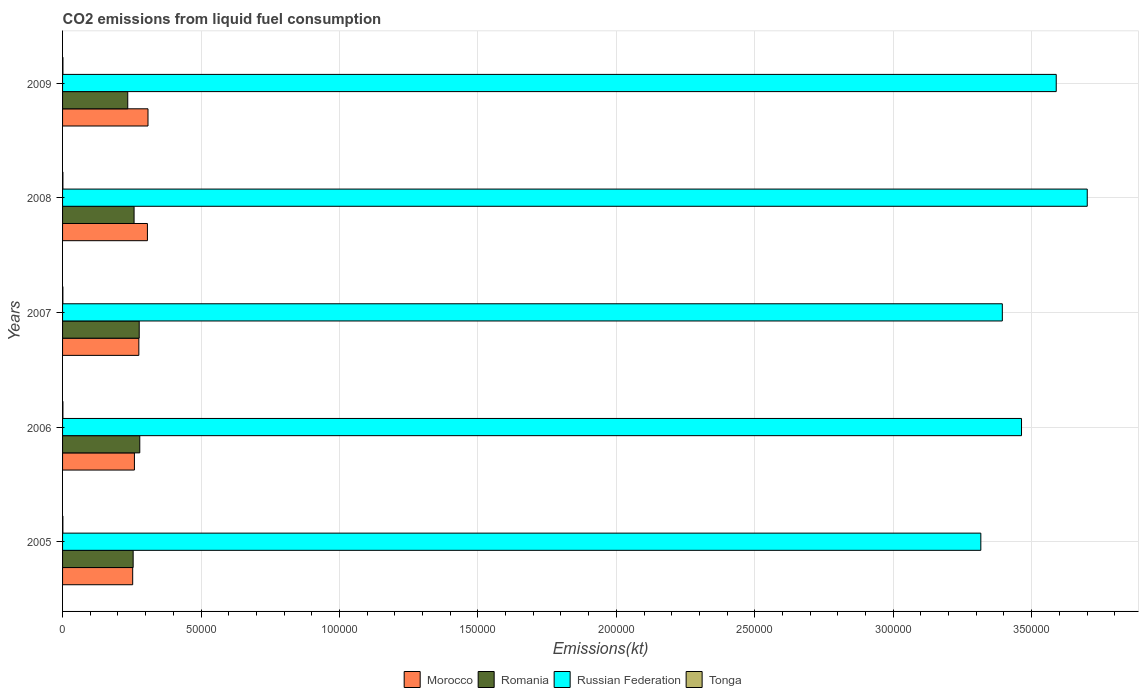How many different coloured bars are there?
Give a very brief answer. 4. How many groups of bars are there?
Provide a short and direct response. 5. Are the number of bars per tick equal to the number of legend labels?
Provide a succinct answer. Yes. Are the number of bars on each tick of the Y-axis equal?
Your answer should be compact. Yes. How many bars are there on the 4th tick from the top?
Offer a terse response. 4. How many bars are there on the 5th tick from the bottom?
Your response must be concise. 4. In how many cases, is the number of bars for a given year not equal to the number of legend labels?
Make the answer very short. 0. What is the amount of CO2 emitted in Morocco in 2005?
Make the answer very short. 2.53e+04. Across all years, what is the maximum amount of CO2 emitted in Russian Federation?
Your answer should be very brief. 3.70e+05. Across all years, what is the minimum amount of CO2 emitted in Russian Federation?
Offer a terse response. 3.32e+05. In which year was the amount of CO2 emitted in Tonga maximum?
Provide a succinct answer. 2009. In which year was the amount of CO2 emitted in Romania minimum?
Keep it short and to the point. 2009. What is the total amount of CO2 emitted in Russian Federation in the graph?
Ensure brevity in your answer.  1.75e+06. What is the difference between the amount of CO2 emitted in Morocco in 2006 and that in 2007?
Provide a short and direct response. -1595.14. What is the difference between the amount of CO2 emitted in Russian Federation in 2008 and the amount of CO2 emitted in Morocco in 2007?
Provide a short and direct response. 3.43e+05. What is the average amount of CO2 emitted in Morocco per year?
Keep it short and to the point. 2.81e+04. In the year 2006, what is the difference between the amount of CO2 emitted in Tonga and amount of CO2 emitted in Russian Federation?
Your answer should be very brief. -3.46e+05. What is the ratio of the amount of CO2 emitted in Romania in 2006 to that in 2008?
Ensure brevity in your answer.  1.08. Is the amount of CO2 emitted in Romania in 2007 less than that in 2008?
Offer a very short reply. No. Is the difference between the amount of CO2 emitted in Tonga in 2006 and 2007 greater than the difference between the amount of CO2 emitted in Russian Federation in 2006 and 2007?
Keep it short and to the point. No. What is the difference between the highest and the second highest amount of CO2 emitted in Romania?
Your answer should be very brief. 205.35. What is the difference between the highest and the lowest amount of CO2 emitted in Morocco?
Make the answer very short. 5529.84. In how many years, is the amount of CO2 emitted in Russian Federation greater than the average amount of CO2 emitted in Russian Federation taken over all years?
Your answer should be very brief. 2. Is the sum of the amount of CO2 emitted in Morocco in 2005 and 2009 greater than the maximum amount of CO2 emitted in Russian Federation across all years?
Give a very brief answer. No. Is it the case that in every year, the sum of the amount of CO2 emitted in Romania and amount of CO2 emitted in Tonga is greater than the sum of amount of CO2 emitted in Russian Federation and amount of CO2 emitted in Morocco?
Your response must be concise. No. What does the 1st bar from the top in 2006 represents?
Make the answer very short. Tonga. What does the 4th bar from the bottom in 2009 represents?
Make the answer very short. Tonga. How many bars are there?
Provide a short and direct response. 20. Are all the bars in the graph horizontal?
Keep it short and to the point. Yes. How many years are there in the graph?
Provide a succinct answer. 5. Does the graph contain grids?
Your answer should be very brief. Yes. How many legend labels are there?
Ensure brevity in your answer.  4. What is the title of the graph?
Make the answer very short. CO2 emissions from liquid fuel consumption. What is the label or title of the X-axis?
Ensure brevity in your answer.  Emissions(kt). What is the Emissions(kt) in Morocco in 2005?
Provide a succinct answer. 2.53e+04. What is the Emissions(kt) in Romania in 2005?
Give a very brief answer. 2.55e+04. What is the Emissions(kt) in Russian Federation in 2005?
Your answer should be very brief. 3.32e+05. What is the Emissions(kt) in Tonga in 2005?
Give a very brief answer. 113.68. What is the Emissions(kt) in Morocco in 2006?
Ensure brevity in your answer.  2.60e+04. What is the Emissions(kt) in Romania in 2006?
Your answer should be very brief. 2.79e+04. What is the Emissions(kt) of Russian Federation in 2006?
Keep it short and to the point. 3.46e+05. What is the Emissions(kt) of Tonga in 2006?
Keep it short and to the point. 128.34. What is the Emissions(kt) of Morocco in 2007?
Offer a very short reply. 2.76e+04. What is the Emissions(kt) of Romania in 2007?
Provide a succinct answer. 2.77e+04. What is the Emissions(kt) in Russian Federation in 2007?
Provide a succinct answer. 3.39e+05. What is the Emissions(kt) in Tonga in 2007?
Offer a terse response. 113.68. What is the Emissions(kt) of Morocco in 2008?
Ensure brevity in your answer.  3.06e+04. What is the Emissions(kt) in Romania in 2008?
Your response must be concise. 2.58e+04. What is the Emissions(kt) of Russian Federation in 2008?
Offer a very short reply. 3.70e+05. What is the Emissions(kt) of Tonga in 2008?
Keep it short and to the point. 121.01. What is the Emissions(kt) of Morocco in 2009?
Your answer should be compact. 3.09e+04. What is the Emissions(kt) of Romania in 2009?
Your answer should be very brief. 2.35e+04. What is the Emissions(kt) of Russian Federation in 2009?
Give a very brief answer. 3.59e+05. What is the Emissions(kt) of Tonga in 2009?
Your response must be concise. 132.01. Across all years, what is the maximum Emissions(kt) in Morocco?
Make the answer very short. 3.09e+04. Across all years, what is the maximum Emissions(kt) in Romania?
Offer a terse response. 2.79e+04. Across all years, what is the maximum Emissions(kt) in Russian Federation?
Provide a succinct answer. 3.70e+05. Across all years, what is the maximum Emissions(kt) in Tonga?
Ensure brevity in your answer.  132.01. Across all years, what is the minimum Emissions(kt) of Morocco?
Provide a short and direct response. 2.53e+04. Across all years, what is the minimum Emissions(kt) of Romania?
Your answer should be compact. 2.35e+04. Across all years, what is the minimum Emissions(kt) in Russian Federation?
Keep it short and to the point. 3.32e+05. Across all years, what is the minimum Emissions(kt) of Tonga?
Provide a short and direct response. 113.68. What is the total Emissions(kt) of Morocco in the graph?
Provide a succinct answer. 1.40e+05. What is the total Emissions(kt) of Romania in the graph?
Ensure brevity in your answer.  1.30e+05. What is the total Emissions(kt) in Russian Federation in the graph?
Provide a short and direct response. 1.75e+06. What is the total Emissions(kt) of Tonga in the graph?
Offer a very short reply. 608.72. What is the difference between the Emissions(kt) in Morocco in 2005 and that in 2006?
Keep it short and to the point. -630.72. What is the difference between the Emissions(kt) of Romania in 2005 and that in 2006?
Provide a succinct answer. -2390.88. What is the difference between the Emissions(kt) in Russian Federation in 2005 and that in 2006?
Make the answer very short. -1.47e+04. What is the difference between the Emissions(kt) in Tonga in 2005 and that in 2006?
Provide a short and direct response. -14.67. What is the difference between the Emissions(kt) in Morocco in 2005 and that in 2007?
Keep it short and to the point. -2225.87. What is the difference between the Emissions(kt) of Romania in 2005 and that in 2007?
Your answer should be very brief. -2185.53. What is the difference between the Emissions(kt) in Russian Federation in 2005 and that in 2007?
Offer a very short reply. -7763.04. What is the difference between the Emissions(kt) in Tonga in 2005 and that in 2007?
Provide a short and direct response. 0. What is the difference between the Emissions(kt) of Morocco in 2005 and that in 2008?
Offer a very short reply. -5320.82. What is the difference between the Emissions(kt) of Romania in 2005 and that in 2008?
Your answer should be compact. -333.7. What is the difference between the Emissions(kt) of Russian Federation in 2005 and that in 2008?
Offer a terse response. -3.84e+04. What is the difference between the Emissions(kt) of Tonga in 2005 and that in 2008?
Make the answer very short. -7.33. What is the difference between the Emissions(kt) of Morocco in 2005 and that in 2009?
Provide a short and direct response. -5529.84. What is the difference between the Emissions(kt) in Romania in 2005 and that in 2009?
Your answer should be compact. 1954.51. What is the difference between the Emissions(kt) in Russian Federation in 2005 and that in 2009?
Provide a short and direct response. -2.72e+04. What is the difference between the Emissions(kt) in Tonga in 2005 and that in 2009?
Ensure brevity in your answer.  -18.34. What is the difference between the Emissions(kt) in Morocco in 2006 and that in 2007?
Your answer should be compact. -1595.14. What is the difference between the Emissions(kt) in Romania in 2006 and that in 2007?
Make the answer very short. 205.35. What is the difference between the Emissions(kt) in Russian Federation in 2006 and that in 2007?
Make the answer very short. 6930.63. What is the difference between the Emissions(kt) in Tonga in 2006 and that in 2007?
Offer a very short reply. 14.67. What is the difference between the Emissions(kt) of Morocco in 2006 and that in 2008?
Your answer should be very brief. -4690.09. What is the difference between the Emissions(kt) in Romania in 2006 and that in 2008?
Provide a succinct answer. 2057.19. What is the difference between the Emissions(kt) in Russian Federation in 2006 and that in 2008?
Offer a terse response. -2.37e+04. What is the difference between the Emissions(kt) in Tonga in 2006 and that in 2008?
Provide a short and direct response. 7.33. What is the difference between the Emissions(kt) in Morocco in 2006 and that in 2009?
Offer a terse response. -4899.11. What is the difference between the Emissions(kt) in Romania in 2006 and that in 2009?
Offer a terse response. 4345.4. What is the difference between the Emissions(kt) of Russian Federation in 2006 and that in 2009?
Your answer should be compact. -1.25e+04. What is the difference between the Emissions(kt) of Tonga in 2006 and that in 2009?
Make the answer very short. -3.67. What is the difference between the Emissions(kt) of Morocco in 2007 and that in 2008?
Make the answer very short. -3094.95. What is the difference between the Emissions(kt) of Romania in 2007 and that in 2008?
Offer a very short reply. 1851.84. What is the difference between the Emissions(kt) of Russian Federation in 2007 and that in 2008?
Provide a short and direct response. -3.07e+04. What is the difference between the Emissions(kt) of Tonga in 2007 and that in 2008?
Provide a short and direct response. -7.33. What is the difference between the Emissions(kt) of Morocco in 2007 and that in 2009?
Offer a very short reply. -3303.97. What is the difference between the Emissions(kt) in Romania in 2007 and that in 2009?
Provide a short and direct response. 4140.04. What is the difference between the Emissions(kt) of Russian Federation in 2007 and that in 2009?
Offer a terse response. -1.95e+04. What is the difference between the Emissions(kt) in Tonga in 2007 and that in 2009?
Make the answer very short. -18.34. What is the difference between the Emissions(kt) of Morocco in 2008 and that in 2009?
Provide a short and direct response. -209.02. What is the difference between the Emissions(kt) in Romania in 2008 and that in 2009?
Ensure brevity in your answer.  2288.21. What is the difference between the Emissions(kt) in Russian Federation in 2008 and that in 2009?
Your response must be concise. 1.12e+04. What is the difference between the Emissions(kt) in Tonga in 2008 and that in 2009?
Ensure brevity in your answer.  -11. What is the difference between the Emissions(kt) in Morocco in 2005 and the Emissions(kt) in Romania in 2006?
Make the answer very short. -2563.23. What is the difference between the Emissions(kt) in Morocco in 2005 and the Emissions(kt) in Russian Federation in 2006?
Provide a short and direct response. -3.21e+05. What is the difference between the Emissions(kt) in Morocco in 2005 and the Emissions(kt) in Tonga in 2006?
Offer a very short reply. 2.52e+04. What is the difference between the Emissions(kt) of Romania in 2005 and the Emissions(kt) of Russian Federation in 2006?
Your response must be concise. -3.21e+05. What is the difference between the Emissions(kt) of Romania in 2005 and the Emissions(kt) of Tonga in 2006?
Make the answer very short. 2.54e+04. What is the difference between the Emissions(kt) in Russian Federation in 2005 and the Emissions(kt) in Tonga in 2006?
Keep it short and to the point. 3.32e+05. What is the difference between the Emissions(kt) in Morocco in 2005 and the Emissions(kt) in Romania in 2007?
Your answer should be compact. -2357.88. What is the difference between the Emissions(kt) of Morocco in 2005 and the Emissions(kt) of Russian Federation in 2007?
Provide a short and direct response. -3.14e+05. What is the difference between the Emissions(kt) in Morocco in 2005 and the Emissions(kt) in Tonga in 2007?
Your answer should be compact. 2.52e+04. What is the difference between the Emissions(kt) of Romania in 2005 and the Emissions(kt) of Russian Federation in 2007?
Provide a succinct answer. -3.14e+05. What is the difference between the Emissions(kt) of Romania in 2005 and the Emissions(kt) of Tonga in 2007?
Your answer should be compact. 2.54e+04. What is the difference between the Emissions(kt) in Russian Federation in 2005 and the Emissions(kt) in Tonga in 2007?
Make the answer very short. 3.32e+05. What is the difference between the Emissions(kt) in Morocco in 2005 and the Emissions(kt) in Romania in 2008?
Your answer should be very brief. -506.05. What is the difference between the Emissions(kt) of Morocco in 2005 and the Emissions(kt) of Russian Federation in 2008?
Keep it short and to the point. -3.45e+05. What is the difference between the Emissions(kt) in Morocco in 2005 and the Emissions(kt) in Tonga in 2008?
Make the answer very short. 2.52e+04. What is the difference between the Emissions(kt) of Romania in 2005 and the Emissions(kt) of Russian Federation in 2008?
Your response must be concise. -3.45e+05. What is the difference between the Emissions(kt) of Romania in 2005 and the Emissions(kt) of Tonga in 2008?
Your response must be concise. 2.54e+04. What is the difference between the Emissions(kt) in Russian Federation in 2005 and the Emissions(kt) in Tonga in 2008?
Your answer should be very brief. 3.32e+05. What is the difference between the Emissions(kt) in Morocco in 2005 and the Emissions(kt) in Romania in 2009?
Provide a short and direct response. 1782.16. What is the difference between the Emissions(kt) in Morocco in 2005 and the Emissions(kt) in Russian Federation in 2009?
Ensure brevity in your answer.  -3.34e+05. What is the difference between the Emissions(kt) of Morocco in 2005 and the Emissions(kt) of Tonga in 2009?
Your response must be concise. 2.52e+04. What is the difference between the Emissions(kt) of Romania in 2005 and the Emissions(kt) of Russian Federation in 2009?
Offer a terse response. -3.33e+05. What is the difference between the Emissions(kt) in Romania in 2005 and the Emissions(kt) in Tonga in 2009?
Your answer should be very brief. 2.54e+04. What is the difference between the Emissions(kt) in Russian Federation in 2005 and the Emissions(kt) in Tonga in 2009?
Offer a terse response. 3.32e+05. What is the difference between the Emissions(kt) in Morocco in 2006 and the Emissions(kt) in Romania in 2007?
Keep it short and to the point. -1727.16. What is the difference between the Emissions(kt) in Morocco in 2006 and the Emissions(kt) in Russian Federation in 2007?
Provide a succinct answer. -3.13e+05. What is the difference between the Emissions(kt) in Morocco in 2006 and the Emissions(kt) in Tonga in 2007?
Provide a succinct answer. 2.58e+04. What is the difference between the Emissions(kt) in Romania in 2006 and the Emissions(kt) in Russian Federation in 2007?
Your answer should be compact. -3.12e+05. What is the difference between the Emissions(kt) in Romania in 2006 and the Emissions(kt) in Tonga in 2007?
Give a very brief answer. 2.78e+04. What is the difference between the Emissions(kt) of Russian Federation in 2006 and the Emissions(kt) of Tonga in 2007?
Provide a succinct answer. 3.46e+05. What is the difference between the Emissions(kt) of Morocco in 2006 and the Emissions(kt) of Romania in 2008?
Your answer should be very brief. 124.68. What is the difference between the Emissions(kt) in Morocco in 2006 and the Emissions(kt) in Russian Federation in 2008?
Keep it short and to the point. -3.44e+05. What is the difference between the Emissions(kt) in Morocco in 2006 and the Emissions(kt) in Tonga in 2008?
Ensure brevity in your answer.  2.58e+04. What is the difference between the Emissions(kt) of Romania in 2006 and the Emissions(kt) of Russian Federation in 2008?
Offer a very short reply. -3.42e+05. What is the difference between the Emissions(kt) of Romania in 2006 and the Emissions(kt) of Tonga in 2008?
Your answer should be compact. 2.78e+04. What is the difference between the Emissions(kt) of Russian Federation in 2006 and the Emissions(kt) of Tonga in 2008?
Your response must be concise. 3.46e+05. What is the difference between the Emissions(kt) of Morocco in 2006 and the Emissions(kt) of Romania in 2009?
Keep it short and to the point. 2412.89. What is the difference between the Emissions(kt) in Morocco in 2006 and the Emissions(kt) in Russian Federation in 2009?
Keep it short and to the point. -3.33e+05. What is the difference between the Emissions(kt) in Morocco in 2006 and the Emissions(kt) in Tonga in 2009?
Provide a short and direct response. 2.58e+04. What is the difference between the Emissions(kt) of Romania in 2006 and the Emissions(kt) of Russian Federation in 2009?
Make the answer very short. -3.31e+05. What is the difference between the Emissions(kt) in Romania in 2006 and the Emissions(kt) in Tonga in 2009?
Offer a very short reply. 2.78e+04. What is the difference between the Emissions(kt) of Russian Federation in 2006 and the Emissions(kt) of Tonga in 2009?
Offer a very short reply. 3.46e+05. What is the difference between the Emissions(kt) in Morocco in 2007 and the Emissions(kt) in Romania in 2008?
Provide a short and direct response. 1719.82. What is the difference between the Emissions(kt) in Morocco in 2007 and the Emissions(kt) in Russian Federation in 2008?
Your response must be concise. -3.43e+05. What is the difference between the Emissions(kt) of Morocco in 2007 and the Emissions(kt) of Tonga in 2008?
Provide a succinct answer. 2.74e+04. What is the difference between the Emissions(kt) of Romania in 2007 and the Emissions(kt) of Russian Federation in 2008?
Your answer should be very brief. -3.42e+05. What is the difference between the Emissions(kt) in Romania in 2007 and the Emissions(kt) in Tonga in 2008?
Your answer should be very brief. 2.76e+04. What is the difference between the Emissions(kt) of Russian Federation in 2007 and the Emissions(kt) of Tonga in 2008?
Offer a very short reply. 3.39e+05. What is the difference between the Emissions(kt) in Morocco in 2007 and the Emissions(kt) in Romania in 2009?
Offer a very short reply. 4008.03. What is the difference between the Emissions(kt) in Morocco in 2007 and the Emissions(kt) in Russian Federation in 2009?
Give a very brief answer. -3.31e+05. What is the difference between the Emissions(kt) of Morocco in 2007 and the Emissions(kt) of Tonga in 2009?
Your response must be concise. 2.74e+04. What is the difference between the Emissions(kt) in Romania in 2007 and the Emissions(kt) in Russian Federation in 2009?
Make the answer very short. -3.31e+05. What is the difference between the Emissions(kt) of Romania in 2007 and the Emissions(kt) of Tonga in 2009?
Give a very brief answer. 2.76e+04. What is the difference between the Emissions(kt) in Russian Federation in 2007 and the Emissions(kt) in Tonga in 2009?
Keep it short and to the point. 3.39e+05. What is the difference between the Emissions(kt) of Morocco in 2008 and the Emissions(kt) of Romania in 2009?
Your answer should be very brief. 7102.98. What is the difference between the Emissions(kt) in Morocco in 2008 and the Emissions(kt) in Russian Federation in 2009?
Your answer should be very brief. -3.28e+05. What is the difference between the Emissions(kt) of Morocco in 2008 and the Emissions(kt) of Tonga in 2009?
Give a very brief answer. 3.05e+04. What is the difference between the Emissions(kt) of Romania in 2008 and the Emissions(kt) of Russian Federation in 2009?
Ensure brevity in your answer.  -3.33e+05. What is the difference between the Emissions(kt) in Romania in 2008 and the Emissions(kt) in Tonga in 2009?
Your answer should be compact. 2.57e+04. What is the difference between the Emissions(kt) in Russian Federation in 2008 and the Emissions(kt) in Tonga in 2009?
Offer a terse response. 3.70e+05. What is the average Emissions(kt) of Morocco per year?
Provide a succinct answer. 2.81e+04. What is the average Emissions(kt) in Romania per year?
Offer a terse response. 2.61e+04. What is the average Emissions(kt) of Russian Federation per year?
Your response must be concise. 3.49e+05. What is the average Emissions(kt) in Tonga per year?
Offer a terse response. 121.74. In the year 2005, what is the difference between the Emissions(kt) of Morocco and Emissions(kt) of Romania?
Offer a very short reply. -172.35. In the year 2005, what is the difference between the Emissions(kt) of Morocco and Emissions(kt) of Russian Federation?
Offer a very short reply. -3.06e+05. In the year 2005, what is the difference between the Emissions(kt) in Morocco and Emissions(kt) in Tonga?
Make the answer very short. 2.52e+04. In the year 2005, what is the difference between the Emissions(kt) in Romania and Emissions(kt) in Russian Federation?
Your answer should be very brief. -3.06e+05. In the year 2005, what is the difference between the Emissions(kt) of Romania and Emissions(kt) of Tonga?
Give a very brief answer. 2.54e+04. In the year 2005, what is the difference between the Emissions(kt) in Russian Federation and Emissions(kt) in Tonga?
Your answer should be compact. 3.32e+05. In the year 2006, what is the difference between the Emissions(kt) of Morocco and Emissions(kt) of Romania?
Your answer should be very brief. -1932.51. In the year 2006, what is the difference between the Emissions(kt) in Morocco and Emissions(kt) in Russian Federation?
Keep it short and to the point. -3.20e+05. In the year 2006, what is the difference between the Emissions(kt) in Morocco and Emissions(kt) in Tonga?
Your answer should be compact. 2.58e+04. In the year 2006, what is the difference between the Emissions(kt) of Romania and Emissions(kt) of Russian Federation?
Your answer should be compact. -3.18e+05. In the year 2006, what is the difference between the Emissions(kt) of Romania and Emissions(kt) of Tonga?
Offer a terse response. 2.78e+04. In the year 2006, what is the difference between the Emissions(kt) in Russian Federation and Emissions(kt) in Tonga?
Your answer should be compact. 3.46e+05. In the year 2007, what is the difference between the Emissions(kt) of Morocco and Emissions(kt) of Romania?
Offer a very short reply. -132.01. In the year 2007, what is the difference between the Emissions(kt) in Morocco and Emissions(kt) in Russian Federation?
Offer a terse response. -3.12e+05. In the year 2007, what is the difference between the Emissions(kt) in Morocco and Emissions(kt) in Tonga?
Keep it short and to the point. 2.74e+04. In the year 2007, what is the difference between the Emissions(kt) of Romania and Emissions(kt) of Russian Federation?
Keep it short and to the point. -3.12e+05. In the year 2007, what is the difference between the Emissions(kt) of Romania and Emissions(kt) of Tonga?
Keep it short and to the point. 2.76e+04. In the year 2007, what is the difference between the Emissions(kt) in Russian Federation and Emissions(kt) in Tonga?
Give a very brief answer. 3.39e+05. In the year 2008, what is the difference between the Emissions(kt) of Morocco and Emissions(kt) of Romania?
Offer a terse response. 4814.77. In the year 2008, what is the difference between the Emissions(kt) of Morocco and Emissions(kt) of Russian Federation?
Provide a short and direct response. -3.39e+05. In the year 2008, what is the difference between the Emissions(kt) in Morocco and Emissions(kt) in Tonga?
Ensure brevity in your answer.  3.05e+04. In the year 2008, what is the difference between the Emissions(kt) of Romania and Emissions(kt) of Russian Federation?
Your answer should be compact. -3.44e+05. In the year 2008, what is the difference between the Emissions(kt) in Romania and Emissions(kt) in Tonga?
Provide a short and direct response. 2.57e+04. In the year 2008, what is the difference between the Emissions(kt) in Russian Federation and Emissions(kt) in Tonga?
Give a very brief answer. 3.70e+05. In the year 2009, what is the difference between the Emissions(kt) in Morocco and Emissions(kt) in Romania?
Give a very brief answer. 7312. In the year 2009, what is the difference between the Emissions(kt) in Morocco and Emissions(kt) in Russian Federation?
Offer a very short reply. -3.28e+05. In the year 2009, what is the difference between the Emissions(kt) in Morocco and Emissions(kt) in Tonga?
Your response must be concise. 3.07e+04. In the year 2009, what is the difference between the Emissions(kt) of Romania and Emissions(kt) of Russian Federation?
Offer a terse response. -3.35e+05. In the year 2009, what is the difference between the Emissions(kt) of Romania and Emissions(kt) of Tonga?
Offer a very short reply. 2.34e+04. In the year 2009, what is the difference between the Emissions(kt) of Russian Federation and Emissions(kt) of Tonga?
Your response must be concise. 3.59e+05. What is the ratio of the Emissions(kt) of Morocco in 2005 to that in 2006?
Your answer should be very brief. 0.98. What is the ratio of the Emissions(kt) in Romania in 2005 to that in 2006?
Your answer should be compact. 0.91. What is the ratio of the Emissions(kt) of Russian Federation in 2005 to that in 2006?
Your answer should be very brief. 0.96. What is the ratio of the Emissions(kt) in Tonga in 2005 to that in 2006?
Offer a terse response. 0.89. What is the ratio of the Emissions(kt) of Morocco in 2005 to that in 2007?
Offer a terse response. 0.92. What is the ratio of the Emissions(kt) in Romania in 2005 to that in 2007?
Your answer should be very brief. 0.92. What is the ratio of the Emissions(kt) in Russian Federation in 2005 to that in 2007?
Offer a very short reply. 0.98. What is the ratio of the Emissions(kt) of Tonga in 2005 to that in 2007?
Provide a succinct answer. 1. What is the ratio of the Emissions(kt) of Morocco in 2005 to that in 2008?
Give a very brief answer. 0.83. What is the ratio of the Emissions(kt) in Romania in 2005 to that in 2008?
Ensure brevity in your answer.  0.99. What is the ratio of the Emissions(kt) of Russian Federation in 2005 to that in 2008?
Provide a short and direct response. 0.9. What is the ratio of the Emissions(kt) in Tonga in 2005 to that in 2008?
Keep it short and to the point. 0.94. What is the ratio of the Emissions(kt) in Morocco in 2005 to that in 2009?
Your answer should be very brief. 0.82. What is the ratio of the Emissions(kt) of Romania in 2005 to that in 2009?
Provide a short and direct response. 1.08. What is the ratio of the Emissions(kt) in Russian Federation in 2005 to that in 2009?
Provide a succinct answer. 0.92. What is the ratio of the Emissions(kt) in Tonga in 2005 to that in 2009?
Keep it short and to the point. 0.86. What is the ratio of the Emissions(kt) in Morocco in 2006 to that in 2007?
Provide a short and direct response. 0.94. What is the ratio of the Emissions(kt) of Romania in 2006 to that in 2007?
Ensure brevity in your answer.  1.01. What is the ratio of the Emissions(kt) in Russian Federation in 2006 to that in 2007?
Provide a succinct answer. 1.02. What is the ratio of the Emissions(kt) of Tonga in 2006 to that in 2007?
Provide a succinct answer. 1.13. What is the ratio of the Emissions(kt) in Morocco in 2006 to that in 2008?
Provide a short and direct response. 0.85. What is the ratio of the Emissions(kt) of Romania in 2006 to that in 2008?
Make the answer very short. 1.08. What is the ratio of the Emissions(kt) of Russian Federation in 2006 to that in 2008?
Ensure brevity in your answer.  0.94. What is the ratio of the Emissions(kt) of Tonga in 2006 to that in 2008?
Provide a succinct answer. 1.06. What is the ratio of the Emissions(kt) of Morocco in 2006 to that in 2009?
Your answer should be very brief. 0.84. What is the ratio of the Emissions(kt) in Romania in 2006 to that in 2009?
Offer a terse response. 1.18. What is the ratio of the Emissions(kt) of Russian Federation in 2006 to that in 2009?
Provide a short and direct response. 0.97. What is the ratio of the Emissions(kt) of Tonga in 2006 to that in 2009?
Make the answer very short. 0.97. What is the ratio of the Emissions(kt) in Morocco in 2007 to that in 2008?
Your response must be concise. 0.9. What is the ratio of the Emissions(kt) of Romania in 2007 to that in 2008?
Your answer should be compact. 1.07. What is the ratio of the Emissions(kt) in Russian Federation in 2007 to that in 2008?
Provide a succinct answer. 0.92. What is the ratio of the Emissions(kt) in Tonga in 2007 to that in 2008?
Your answer should be compact. 0.94. What is the ratio of the Emissions(kt) of Morocco in 2007 to that in 2009?
Your answer should be compact. 0.89. What is the ratio of the Emissions(kt) in Romania in 2007 to that in 2009?
Offer a terse response. 1.18. What is the ratio of the Emissions(kt) in Russian Federation in 2007 to that in 2009?
Offer a terse response. 0.95. What is the ratio of the Emissions(kt) of Tonga in 2007 to that in 2009?
Provide a short and direct response. 0.86. What is the ratio of the Emissions(kt) of Romania in 2008 to that in 2009?
Your answer should be compact. 1.1. What is the ratio of the Emissions(kt) in Russian Federation in 2008 to that in 2009?
Provide a succinct answer. 1.03. What is the difference between the highest and the second highest Emissions(kt) in Morocco?
Your response must be concise. 209.02. What is the difference between the highest and the second highest Emissions(kt) in Romania?
Your response must be concise. 205.35. What is the difference between the highest and the second highest Emissions(kt) of Russian Federation?
Your answer should be very brief. 1.12e+04. What is the difference between the highest and the second highest Emissions(kt) in Tonga?
Your response must be concise. 3.67. What is the difference between the highest and the lowest Emissions(kt) in Morocco?
Give a very brief answer. 5529.84. What is the difference between the highest and the lowest Emissions(kt) in Romania?
Make the answer very short. 4345.4. What is the difference between the highest and the lowest Emissions(kt) of Russian Federation?
Make the answer very short. 3.84e+04. What is the difference between the highest and the lowest Emissions(kt) of Tonga?
Provide a succinct answer. 18.34. 